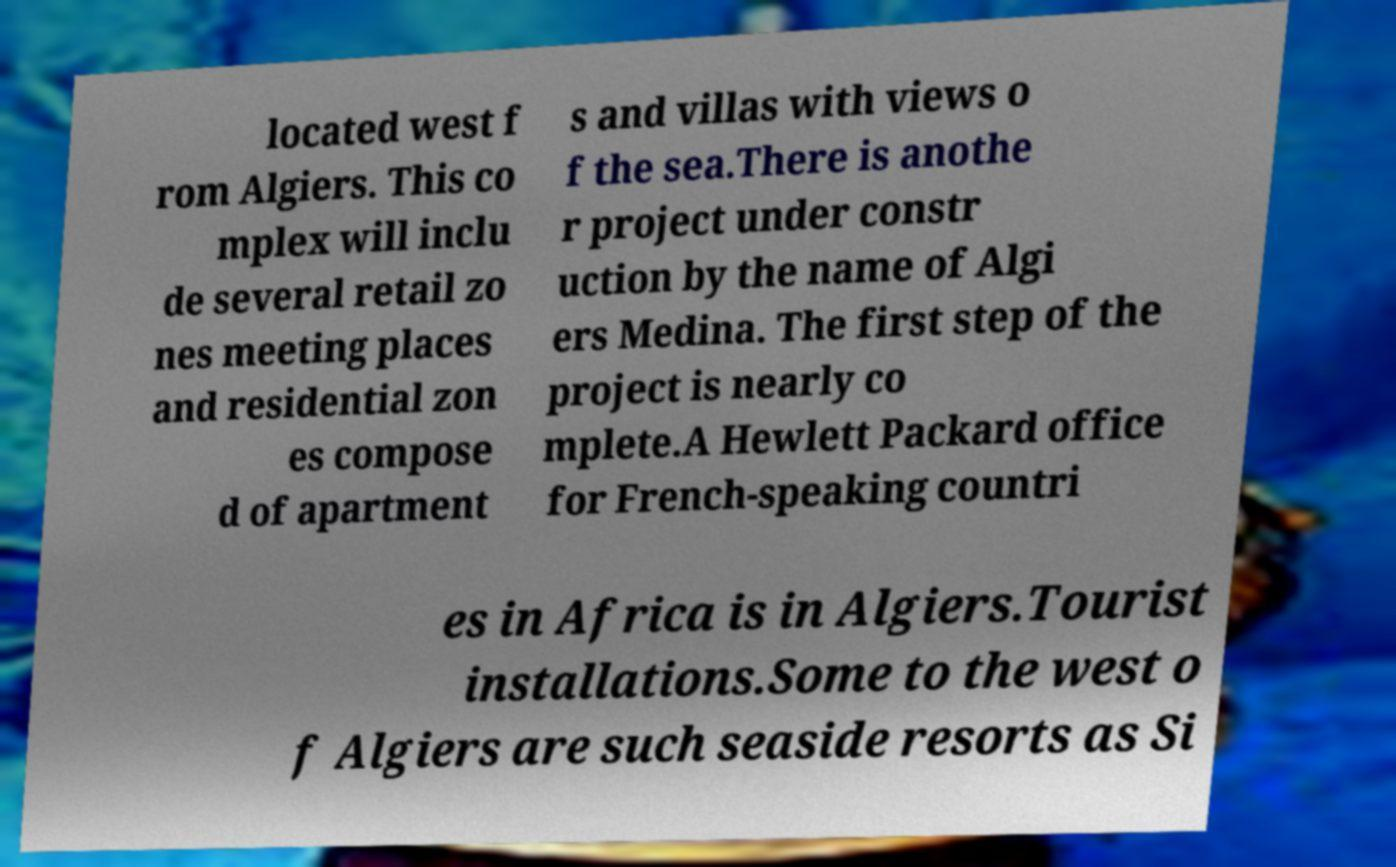Could you extract and type out the text from this image? located west f rom Algiers. This co mplex will inclu de several retail zo nes meeting places and residential zon es compose d of apartment s and villas with views o f the sea.There is anothe r project under constr uction by the name of Algi ers Medina. The first step of the project is nearly co mplete.A Hewlett Packard office for French-speaking countri es in Africa is in Algiers.Tourist installations.Some to the west o f Algiers are such seaside resorts as Si 